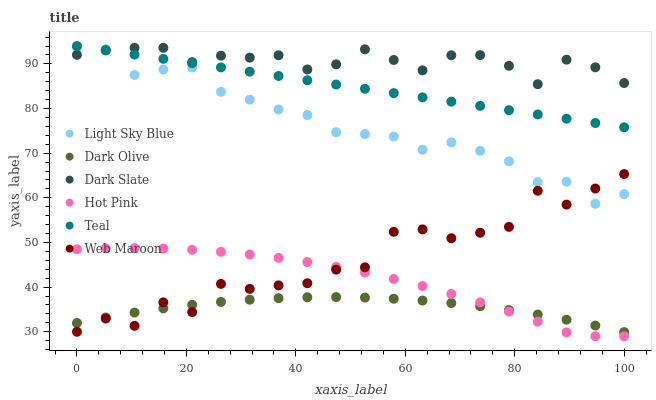Does Dark Olive have the minimum area under the curve?
Answer yes or no. Yes. Does Dark Slate have the maximum area under the curve?
Answer yes or no. Yes. Does Web Maroon have the minimum area under the curve?
Answer yes or no. No. Does Web Maroon have the maximum area under the curve?
Answer yes or no. No. Is Teal the smoothest?
Answer yes or no. Yes. Is Web Maroon the roughest?
Answer yes or no. Yes. Is Dark Olive the smoothest?
Answer yes or no. No. Is Dark Olive the roughest?
Answer yes or no. No. Does Hot Pink have the lowest value?
Answer yes or no. Yes. Does Dark Olive have the lowest value?
Answer yes or no. No. Does Teal have the highest value?
Answer yes or no. Yes. Does Web Maroon have the highest value?
Answer yes or no. No. Is Hot Pink less than Dark Slate?
Answer yes or no. Yes. Is Light Sky Blue greater than Dark Olive?
Answer yes or no. Yes. Does Light Sky Blue intersect Dark Slate?
Answer yes or no. Yes. Is Light Sky Blue less than Dark Slate?
Answer yes or no. No. Is Light Sky Blue greater than Dark Slate?
Answer yes or no. No. Does Hot Pink intersect Dark Slate?
Answer yes or no. No. 